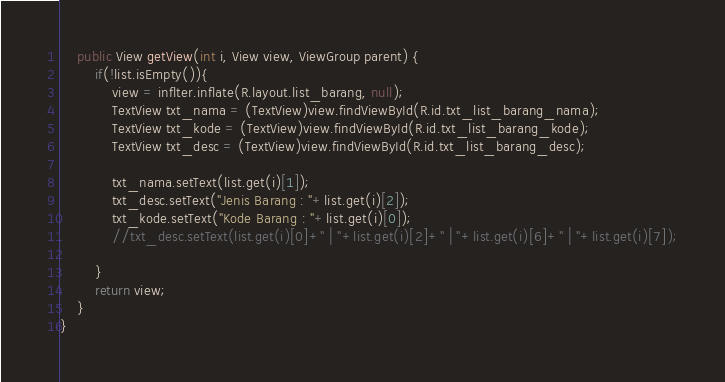Convert code to text. <code><loc_0><loc_0><loc_500><loc_500><_Java_>    public View getView(int i, View view, ViewGroup parent) {
        if(!list.isEmpty()){
            view = inflter.inflate(R.layout.list_barang, null);
            TextView txt_nama = (TextView)view.findViewById(R.id.txt_list_barang_nama);
            TextView txt_kode = (TextView)view.findViewById(R.id.txt_list_barang_kode);
            TextView txt_desc = (TextView)view.findViewById(R.id.txt_list_barang_desc);

            txt_nama.setText(list.get(i)[1]);
            txt_desc.setText("Jenis Barang : "+list.get(i)[2]);
            txt_kode.setText("Kode Barang : "+list.get(i)[0]);
            //txt_desc.setText(list.get(i)[0]+" | "+list.get(i)[2]+" | "+list.get(i)[6]+" | "+list.get(i)[7]);

        }
        return view;
    }
}
</code> 